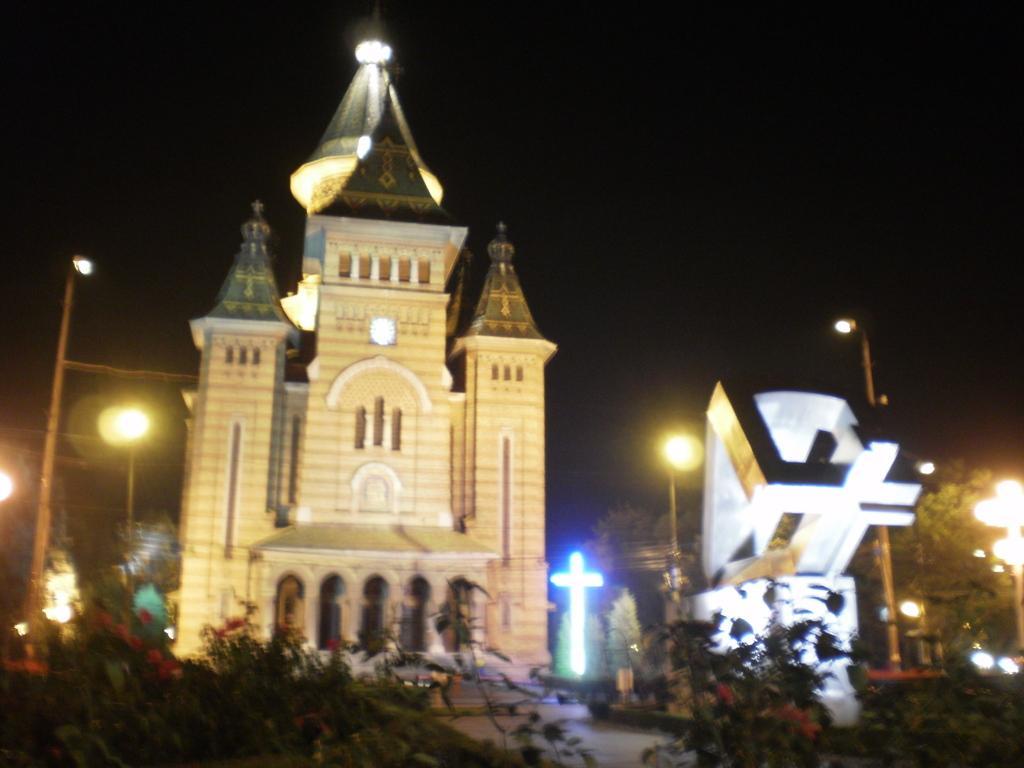Describe this image in one or two sentences. In this image I can see few trees, poles, lights and buildings. I can see this image is little bit in dark from background. 